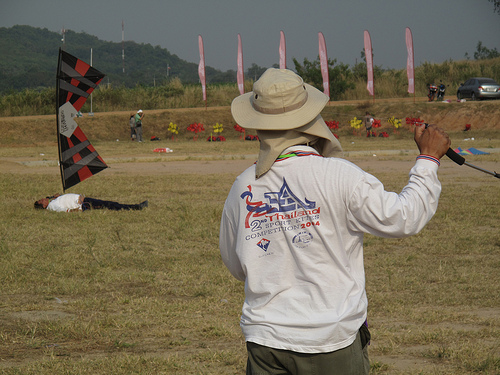<image>
Is the banner to the left of the stick? No. The banner is not to the left of the stick. From this viewpoint, they have a different horizontal relationship. 